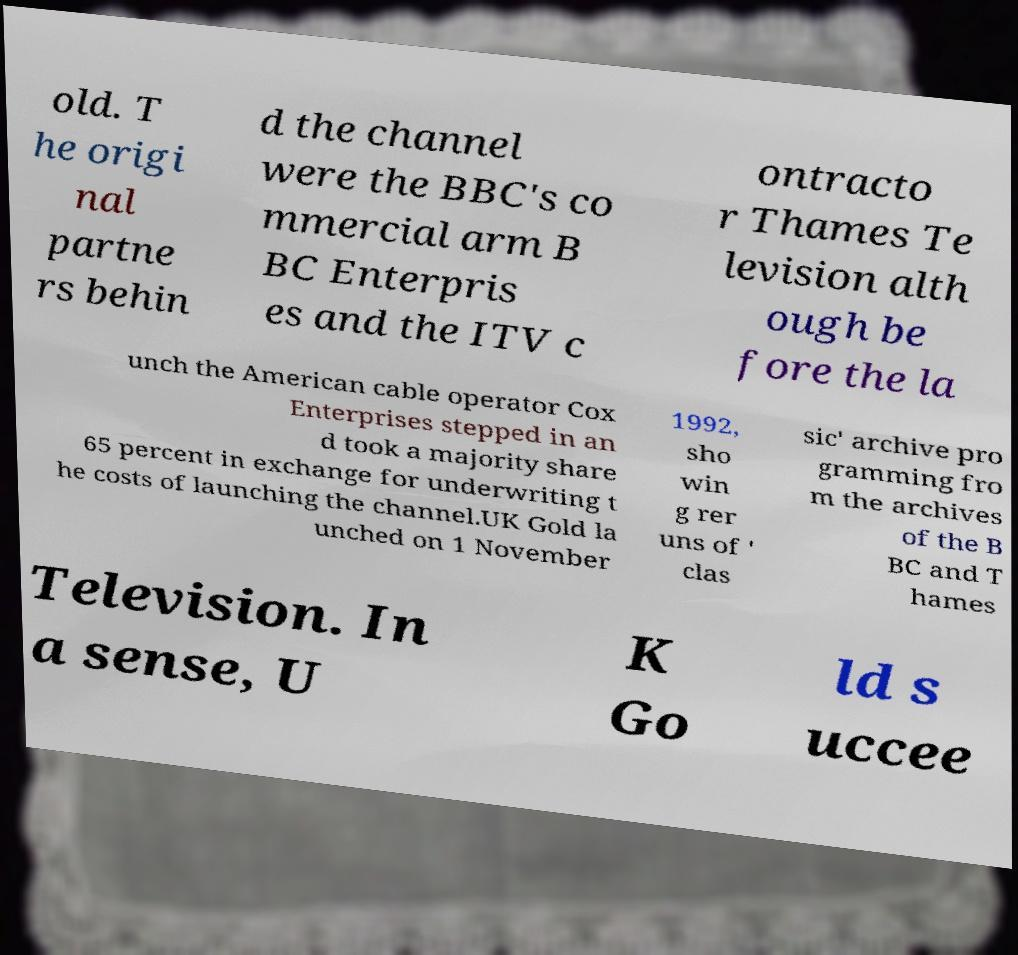For documentation purposes, I need the text within this image transcribed. Could you provide that? old. T he origi nal partne rs behin d the channel were the BBC's co mmercial arm B BC Enterpris es and the ITV c ontracto r Thames Te levision alth ough be fore the la unch the American cable operator Cox Enterprises stepped in an d took a majority share 65 percent in exchange for underwriting t he costs of launching the channel.UK Gold la unched on 1 November 1992, sho win g rer uns of ' clas sic' archive pro gramming fro m the archives of the B BC and T hames Television. In a sense, U K Go ld s uccee 